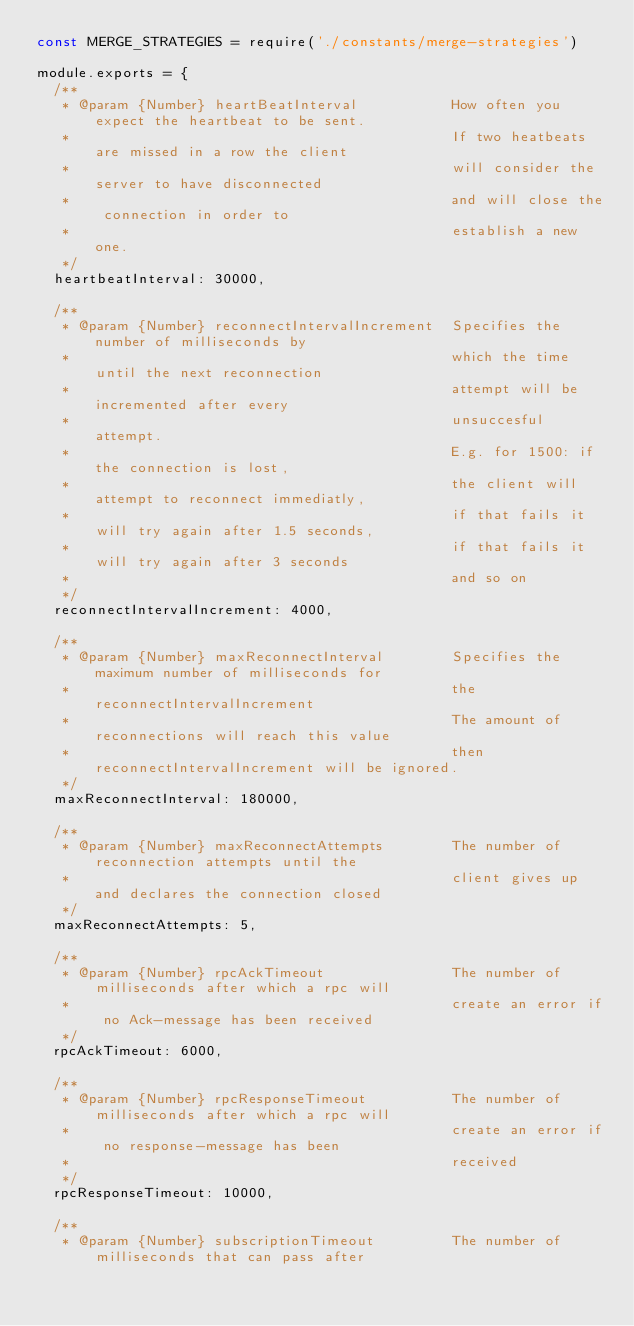Convert code to text. <code><loc_0><loc_0><loc_500><loc_500><_JavaScript_>const MERGE_STRATEGIES = require('./constants/merge-strategies')

module.exports = {
  /**
   * @param {Number} heartBeatInterval           How often you expect the heartbeat to be sent.
   *                                             If two heatbeats are missed in a row the client
   *                                             will consider the server to have disconnected
   *                                             and will close the connection in order to
   *                                             establish a new one.
   */
  heartbeatInterval: 30000,

  /**
   * @param {Number} reconnectIntervalIncrement  Specifies the number of milliseconds by
   *                                             which the time until the next reconnection
   *                                             attempt will be incremented after every
   *                                             unsuccesful attempt.
   *                                             E.g. for 1500: if the connection is lost,
   *                                             the client will attempt to reconnect immediatly,
   *                                             if that fails it will try again after 1.5 seconds,
   *                                             if that fails it will try again after 3 seconds
   *                                             and so on
   */
  reconnectIntervalIncrement: 4000,

  /**
   * @param {Number} maxReconnectInterval        Specifies the maximum number of milliseconds for
   *                                             the reconnectIntervalIncrement
   *                                             The amount of reconnections will reach this value
   *                                             then reconnectIntervalIncrement will be ignored.
   */
  maxReconnectInterval: 180000,

  /**
   * @param {Number} maxReconnectAttempts        The number of reconnection attempts until the
   *                                             client gives up and declares the connection closed
   */
  maxReconnectAttempts: 5,

  /**
   * @param {Number} rpcAckTimeout               The number of milliseconds after which a rpc will
   *                                             create an error if no Ack-message has been received
   */
  rpcAckTimeout: 6000,

  /**
   * @param {Number} rpcResponseTimeout          The number of milliseconds after which a rpc will
   *                                             create an error if no response-message has been
   *                                             received
   */
  rpcResponseTimeout: 10000,

  /**
   * @param {Number} subscriptionTimeout         The number of milliseconds that can pass after</code> 